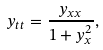Convert formula to latex. <formula><loc_0><loc_0><loc_500><loc_500>y _ { t t } = \frac { y _ { x x } } { 1 + y ^ { 2 } _ { x } } ,</formula> 